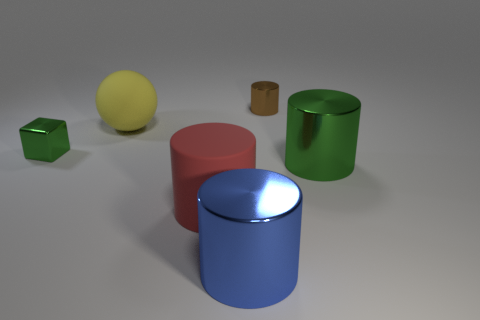What is the shape of the green metallic object that is on the right side of the shiny cylinder behind the large green metallic cylinder?
Ensure brevity in your answer.  Cylinder. What number of small things are brown cylinders or metal cylinders?
Offer a terse response. 1. There is a tiny shiny object that is on the right side of the large blue metallic cylinder; is its color the same as the small metallic thing that is left of the red cylinder?
Your answer should be compact. No. How many other things are there of the same color as the shiny block?
Offer a very short reply. 1. There is a large matte thing in front of the yellow matte ball; what shape is it?
Your answer should be compact. Cylinder. Are there fewer yellow matte things than brown metallic balls?
Offer a very short reply. No. Is the cylinder to the right of the brown cylinder made of the same material as the small cylinder?
Offer a terse response. Yes. Are there any other things that are the same size as the blue cylinder?
Keep it short and to the point. Yes. Are there any tiny objects to the left of the large yellow ball?
Offer a terse response. Yes. There is a metallic thing in front of the big metal cylinder right of the big shiny cylinder that is in front of the green cylinder; what is its color?
Give a very brief answer. Blue. 